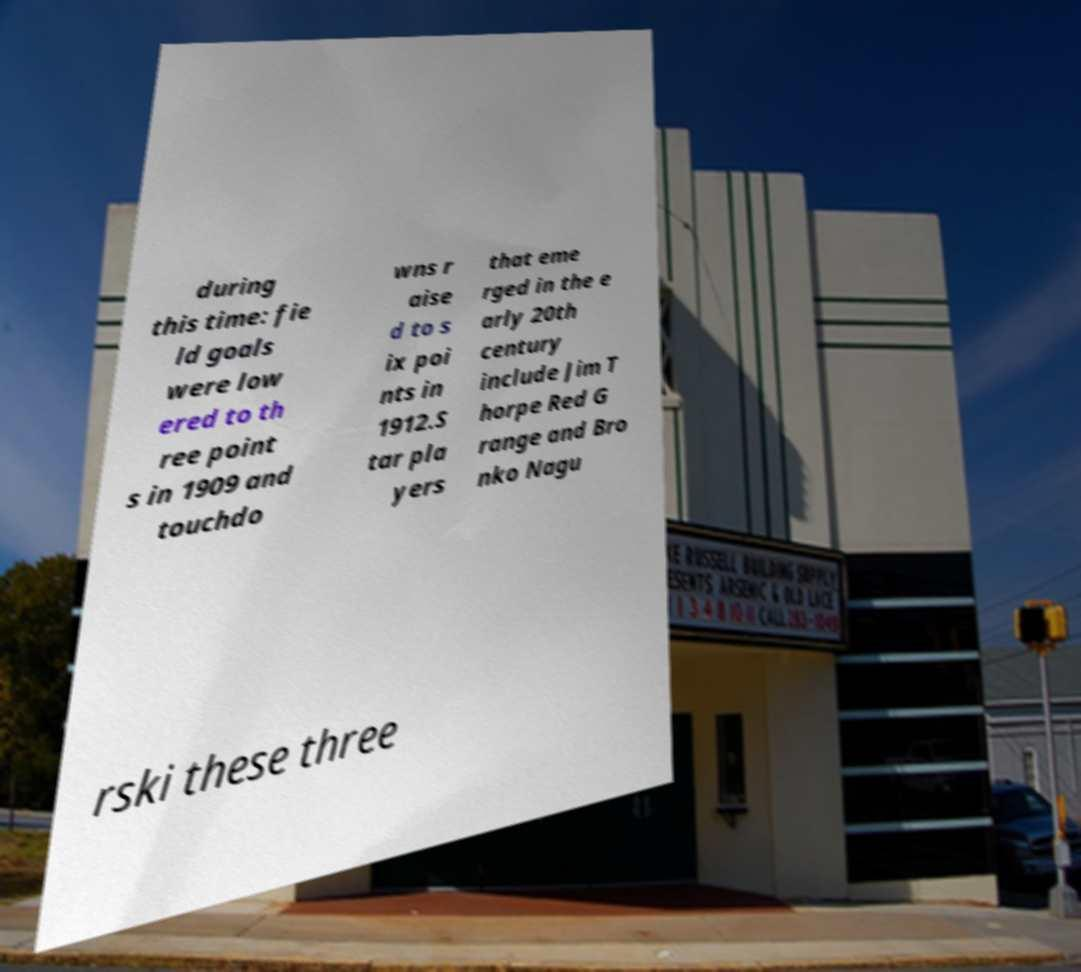Please identify and transcribe the text found in this image. during this time: fie ld goals were low ered to th ree point s in 1909 and touchdo wns r aise d to s ix poi nts in 1912.S tar pla yers that eme rged in the e arly 20th century include Jim T horpe Red G range and Bro nko Nagu rski these three 